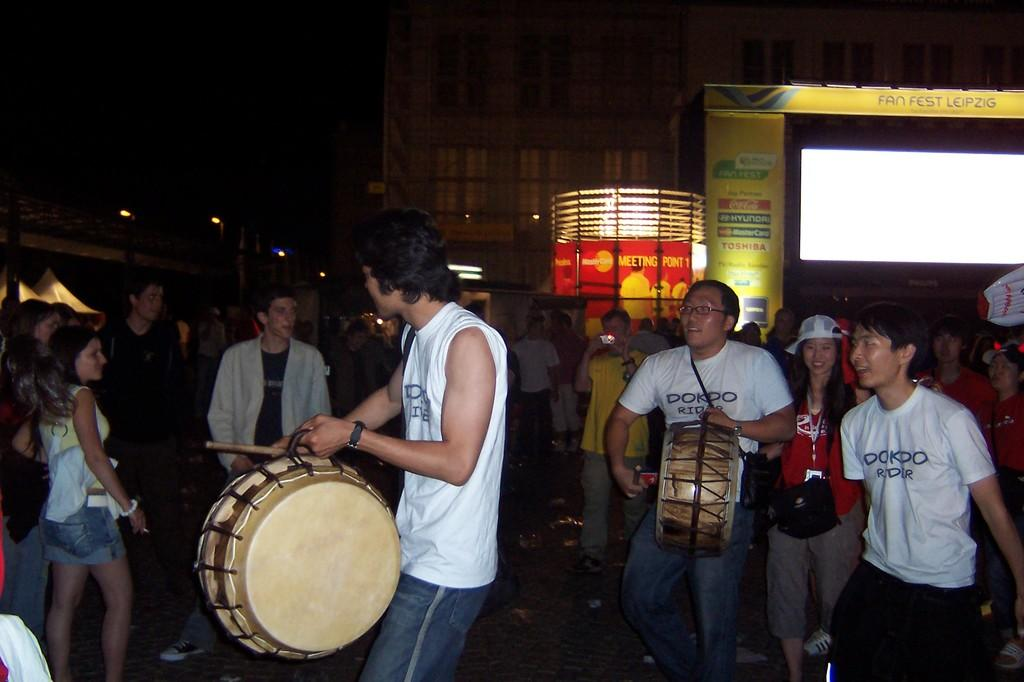What are the people in the image doing? The people in the image are standing on the road. What activity can be seen being performed by some individuals in the image? There are men playing drums in the image. What structure is present in the image that might be used for performances? There is a stage with lights in the image. What can be seen in the distance behind the stage? There is a building visible in the background. What type of dress is hanging on the jar in the image? There is no dress or jar present in the image. How many cherries are on the stage in the image? There are no cherries present in the image. 